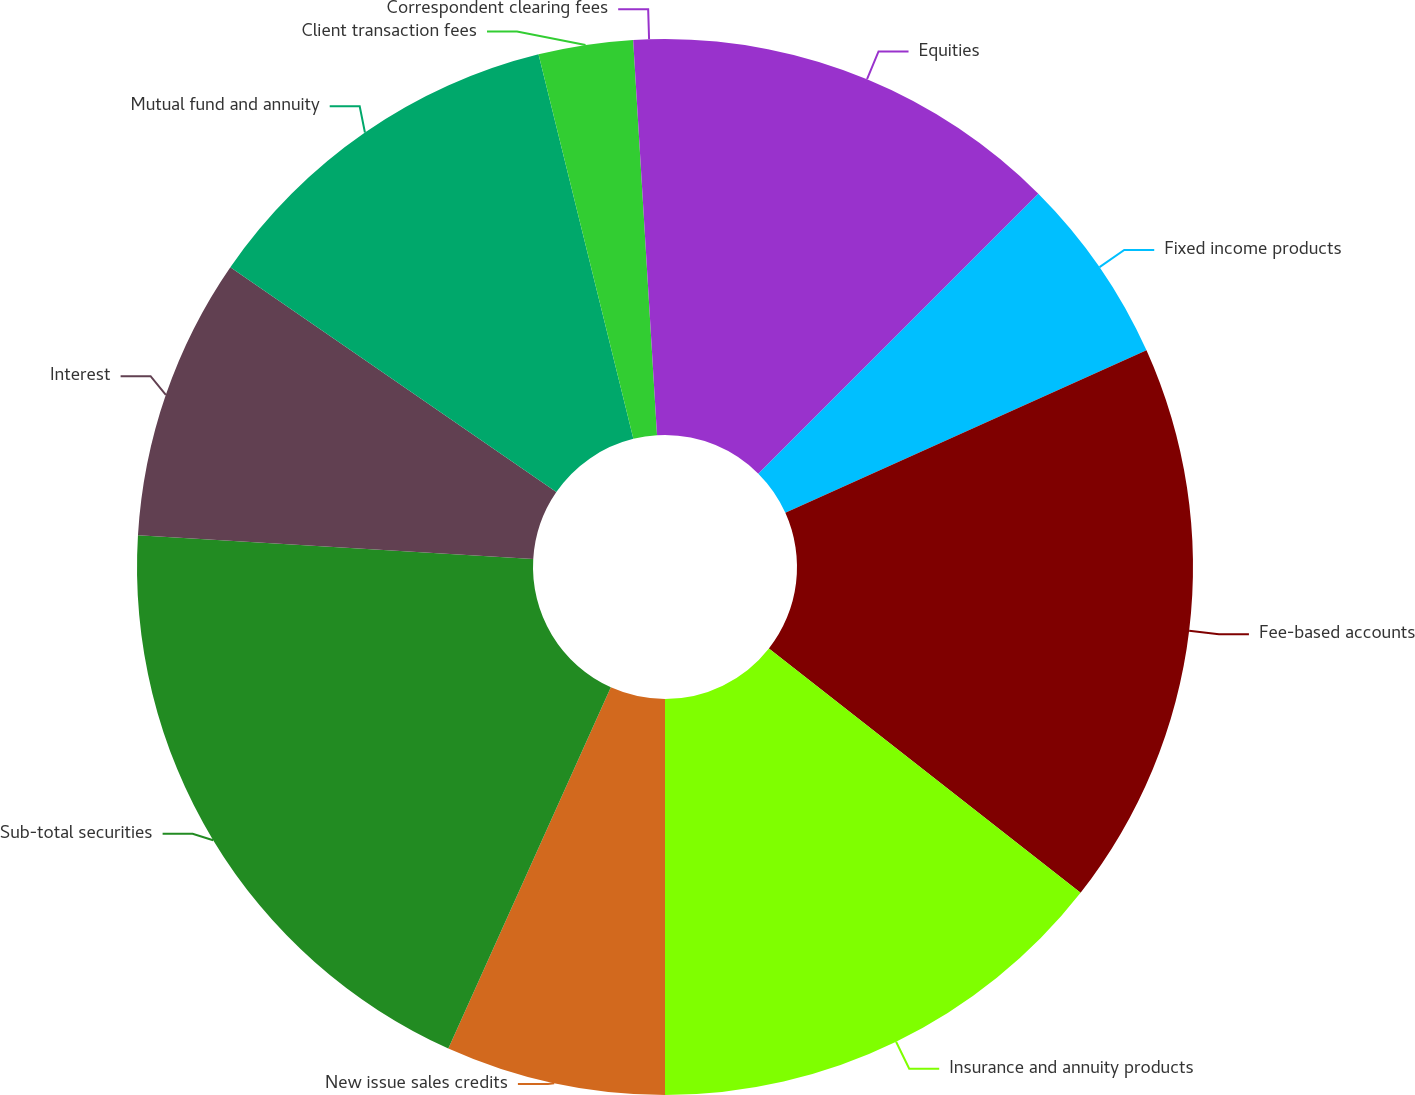Convert chart. <chart><loc_0><loc_0><loc_500><loc_500><pie_chart><fcel>Equities<fcel>Fixed income products<fcel>Fee-based accounts<fcel>Insurance and annuity products<fcel>New issue sales credits<fcel>Sub-total securities<fcel>Interest<fcel>Mutual fund and annuity<fcel>Client transaction fees<fcel>Correspondent clearing fees<nl><fcel>12.5%<fcel>5.77%<fcel>17.31%<fcel>14.42%<fcel>6.73%<fcel>19.23%<fcel>8.65%<fcel>11.54%<fcel>2.89%<fcel>0.96%<nl></chart> 